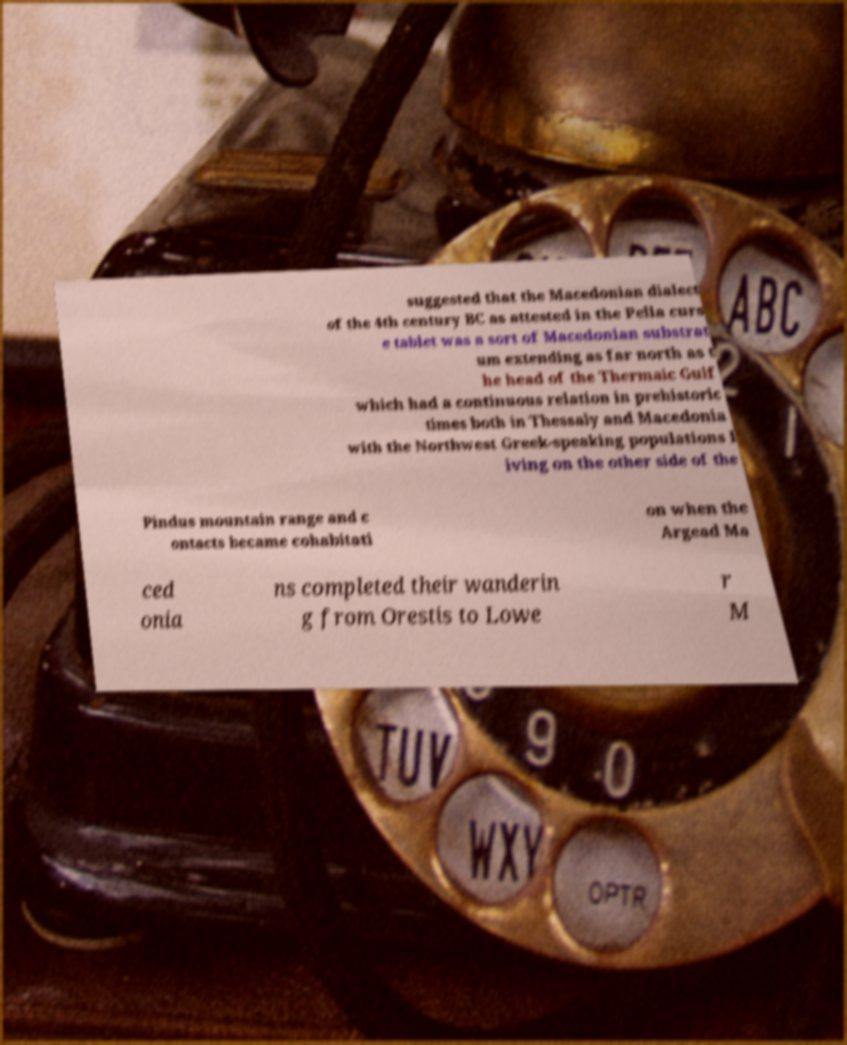Can you read and provide the text displayed in the image?This photo seems to have some interesting text. Can you extract and type it out for me? suggested that the Macedonian dialect of the 4th century BC as attested in the Pella curs e tablet was a sort of Macedonian substrat um extending as far north as t he head of the Thermaic Gulf which had a continuous relation in prehistoric times both in Thessaly and Macedonia with the Northwest Greek-speaking populations l iving on the other side of the Pindus mountain range and c ontacts became cohabitati on when the Argead Ma ced onia ns completed their wanderin g from Orestis to Lowe r M 